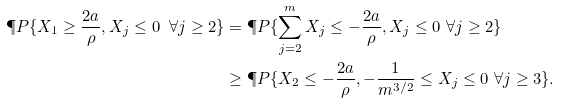<formula> <loc_0><loc_0><loc_500><loc_500>\P P \{ X _ { 1 } \geq \frac { 2 a } { \rho } , X _ { j } \leq 0 \ \forall j \geq 2 \} & = \P P \{ \sum _ { j = 2 } ^ { m } X _ { j } \leq - \frac { 2 a } { \rho } , X _ { j } \leq 0 \ \forall j \geq 2 \} \\ & \geq \P P \{ X _ { 2 } \leq - \frac { 2 a } { \rho } , - \frac { 1 } { m ^ { 3 / 2 } } \leq X _ { j } \leq 0 \ \forall j \geq 3 \} .</formula> 